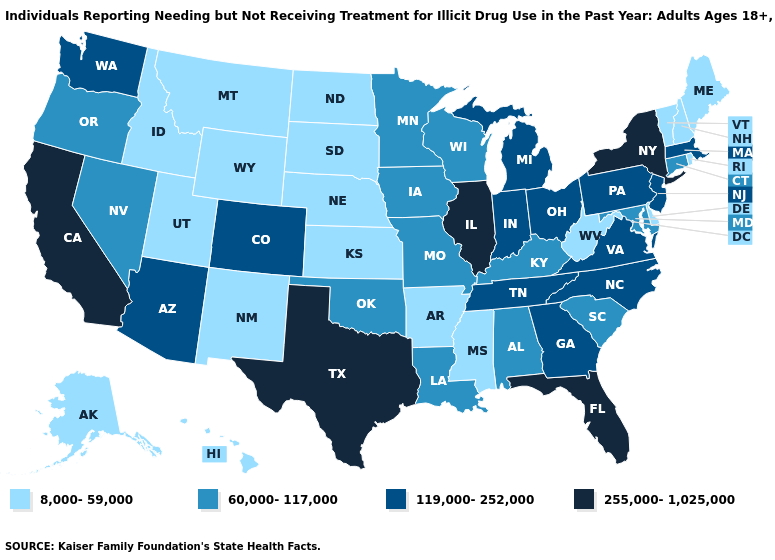What is the lowest value in the USA?
Answer briefly. 8,000-59,000. Among the states that border Utah , which have the highest value?
Give a very brief answer. Arizona, Colorado. Is the legend a continuous bar?
Keep it brief. No. Does Kansas have the lowest value in the MidWest?
Short answer required. Yes. What is the value of Arkansas?
Short answer required. 8,000-59,000. What is the lowest value in states that border Arizona?
Give a very brief answer. 8,000-59,000. Among the states that border Kentucky , which have the lowest value?
Quick response, please. West Virginia. What is the value of Minnesota?
Keep it brief. 60,000-117,000. Which states have the highest value in the USA?
Quick response, please. California, Florida, Illinois, New York, Texas. What is the value of Arkansas?
Quick response, please. 8,000-59,000. What is the value of Virginia?
Keep it brief. 119,000-252,000. How many symbols are there in the legend?
Give a very brief answer. 4. Does Arizona have the lowest value in the West?
Short answer required. No. Among the states that border Illinois , does Indiana have the lowest value?
Concise answer only. No. Among the states that border Illinois , which have the lowest value?
Answer briefly. Iowa, Kentucky, Missouri, Wisconsin. 